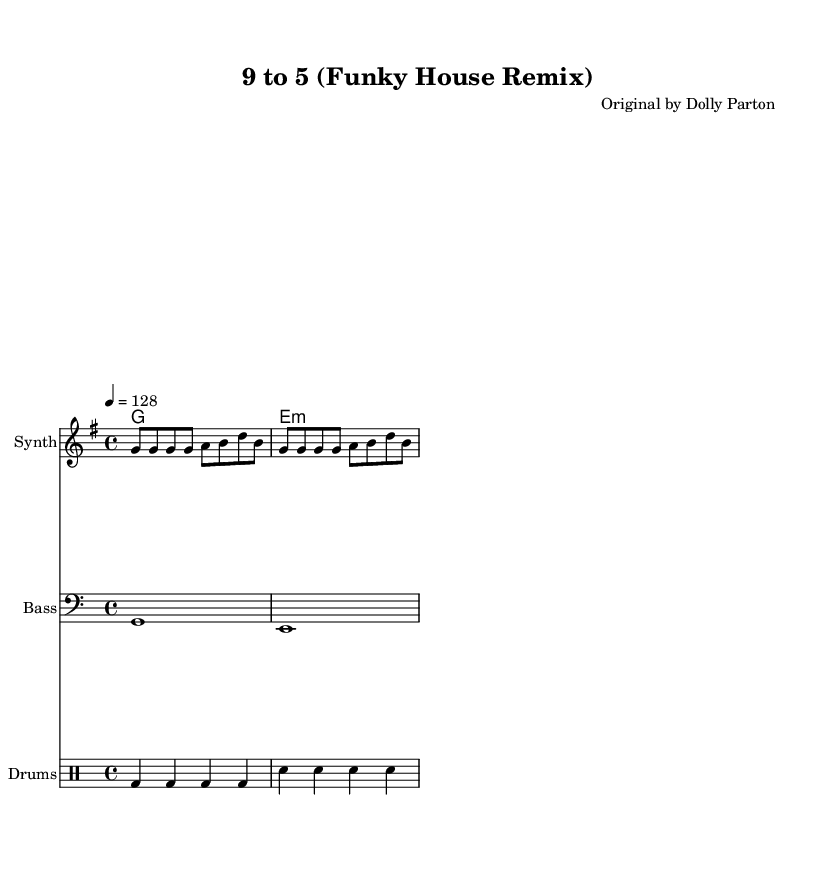What is the key signature of this music? The key signature is G major, which has one sharp (F#). It can be determined by looking at the symbol at the beginning of the staff, indicating the sharp note.
Answer: G major What is the time signature of this music? The time signature is 4/4, indicated by the fraction found in the beginning of the score. This means there are four beats in a measure.
Answer: 4/4 What is the tempo marking for this piece? The tempo marking is 128 BPM, indicated by the number written at the beginning of the score. BPM stands for beats per minute and it tells how fast the music is to be played.
Answer: 128 Which instrument is playing the melody? The melody is played by a Synth, as indicated in the staff labeling in the score. It shows which instrument is responsible for playing that part.
Answer: Synth What type of chords are used in the harmony? The harmony includes a major chord (G major) and a minor chord (E minor). This is evident from the chord symbols presented above the staff.
Answer: Major and minor How many measures are there in the melody section? There are four measures in the melody section, which can be counted based on the bars separating the notes. Each measure is divided by vertical lines on the staff.
Answer: 4 What kind of rhythmic pattern is used in the drums? The drums have a consistent beat pattern, featuring bass and snare hits in a structured manner, which is characteristic of House music rhythm. The rhythmic cues can be seen in the drummode section.
Answer: Consistent beat 